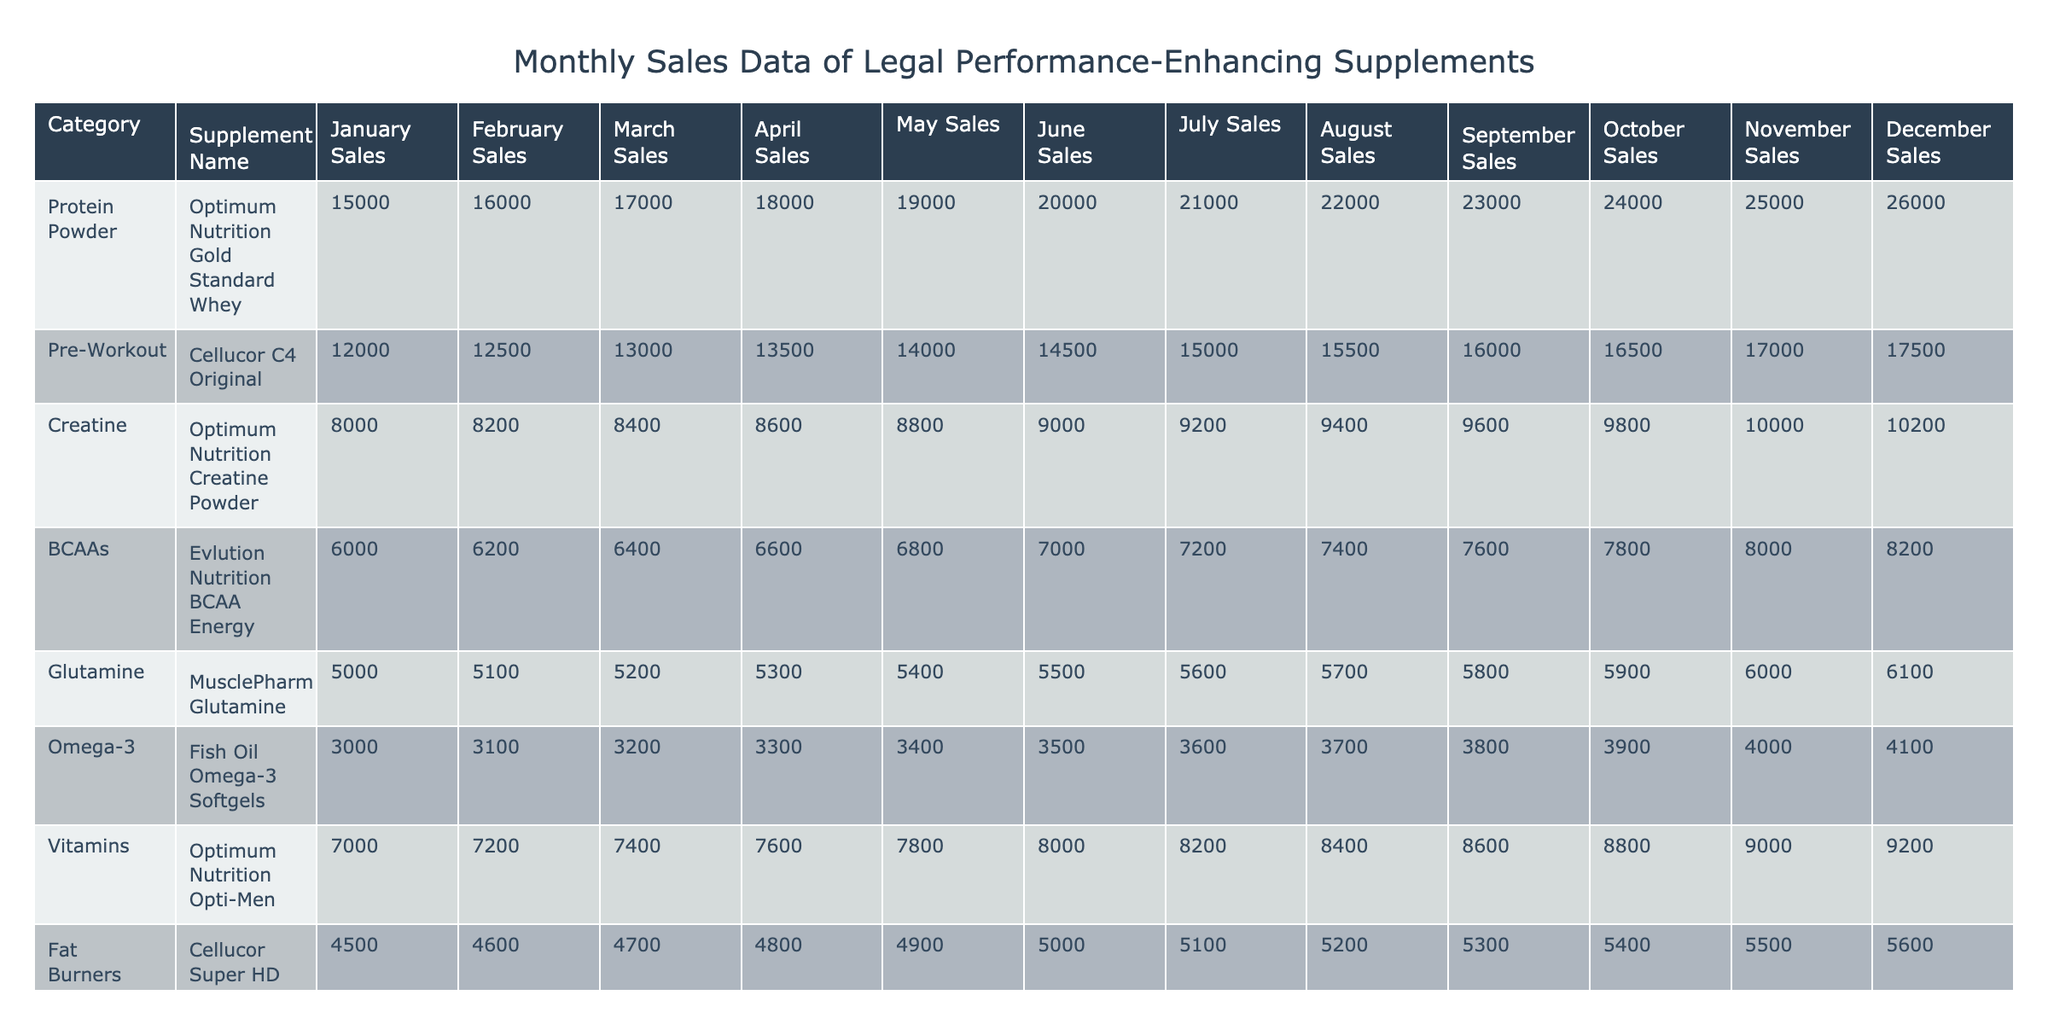What was the total sales of Optimum Nutrition Gold Standard Whey in the first quarter (January to March)? To find the total sales for the first quarter, add the sales for January, February, and March: 15000 + 16000 + 17000 = 48000.
Answer: 48000 Which supplement category had the highest sales in December? Looking at the December sales column, Protein Powder has sales of 26000, which is higher than any other category listed.
Answer: Protein Powder Did the sales of Fish Oil Omega-3 Softgels increase or decrease from January to December? January sales were 3000 and December sales were 4100. Since December sales are higher than January sales, this indicates an increase.
Answer: Increase What is the average monthly sales of Cellucor C4 Original over the year? To find the average monthly sales, sum the sales for each month (12000 + 12500 + 13000 + 13500 + 14000 + 14500 + 15000 + 15500 + 16000 + 16500 + 17000 + 17500 = 168000) and then divide by 12, which results in 168000 / 12 = 14000.
Answer: 14000 Which supplement had the lowest total sales across the year? By adding up the total sales for each supplement, we find that Nutrabolics Test, with totals of 2500 + 2600 + 2700 + 2800 + 2900 + 3000 + 3100 + 3200 + 3300 + 3400 + 3500 + 3600 = 36000, is the lowest total compared to the others.
Answer: Nutrabolics Test In which month did Protein Powder experience the largest sales increase? By comparing the monthly sales increases, the largest increase for Protein Powder is from November (25000) to December (26000), which is an increase of 1000.
Answer: December What is the total sales of all categories combined for the year? The total sales for each supplement category are summed: (150000 + 170000 + 110000 + 86000 + 67000 + 45000 + 99000 + 66000 + 60000 + 42000 = 660000).
Answer: 660000 Did any category have sales that exceeded 20000 in more than half of the months? Protein Powder had sales above 20000 in July (21000), August (22000), September (23000), October (24000), November (25000), and December (26000), totaling 6 months, thus exceeding 20000 in more than half of the months.
Answer: Yes Which supplement category showed the most consistent increase throughout the year? Analyzing the sales data, Protein Powder showed a consistent increase from January to December, with monthly sales increasing every month without any decrease.
Answer: Protein Powder How much more did L-Arginine sell in July than in February? The sales for L-Arginine in July are 4600, while in February they are 4100. The difference is 4600 - 4100 = 500.
Answer: 500 What was the average sales for Glutamine across the entire year? Sum the monthly sales for Glutamine (5000 + 5100 + 5200 + 5300 + 5400 + 5500 + 5600 + 5700 + 5800 + 5900 + 6000 + 6100 = 65100) and divide by 12, which gives an average of 65100 / 12 = 5425.
Answer: 5425 